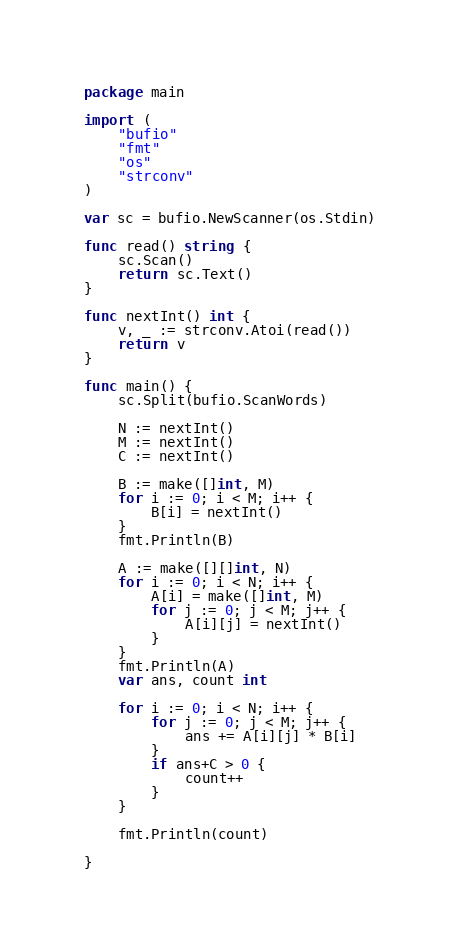<code> <loc_0><loc_0><loc_500><loc_500><_Go_>package main

import (
	"bufio"
	"fmt"
	"os"
	"strconv"
)

var sc = bufio.NewScanner(os.Stdin)

func read() string {
	sc.Scan()
	return sc.Text()
}

func nextInt() int {
	v, _ := strconv.Atoi(read())
	return v
}

func main() {
	sc.Split(bufio.ScanWords)

	N := nextInt()
	M := nextInt()
	C := nextInt()

	B := make([]int, M)
	for i := 0; i < M; i++ {
		B[i] = nextInt()
	}
	fmt.Println(B)

	A := make([][]int, N)
	for i := 0; i < N; i++ {
		A[i] = make([]int, M)
		for j := 0; j < M; j++ {
			A[i][j] = nextInt()
		}
	}
	fmt.Println(A)
	var ans, count int

	for i := 0; i < N; i++ {
		for j := 0; j < M; j++ {
			ans += A[i][j] * B[i]
		}
		if ans+C > 0 {
			count++
		}
	}

	fmt.Println(count)

}
</code> 